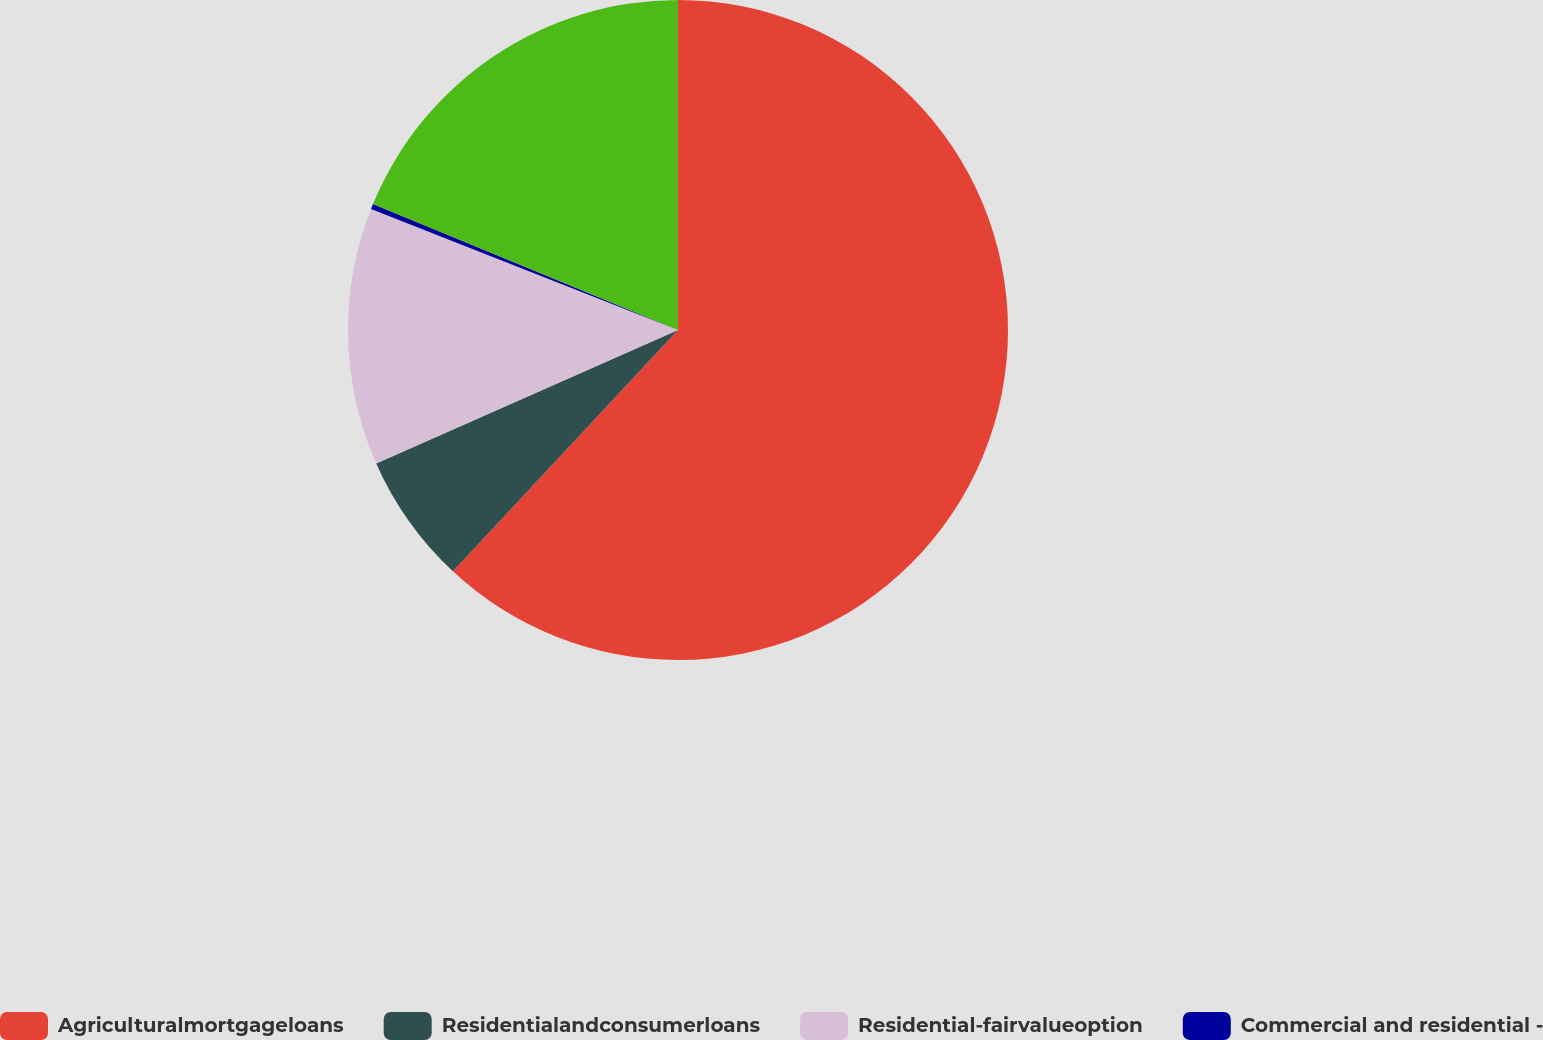Convert chart to OTSL. <chart><loc_0><loc_0><loc_500><loc_500><pie_chart><fcel>Agriculturalmortgageloans<fcel>Residentialandconsumerloans<fcel>Residential-fairvalueoption<fcel>Commercial and residential -<fcel>Unnamed: 4<nl><fcel>61.95%<fcel>6.43%<fcel>12.6%<fcel>0.26%<fcel>18.77%<nl></chart> 